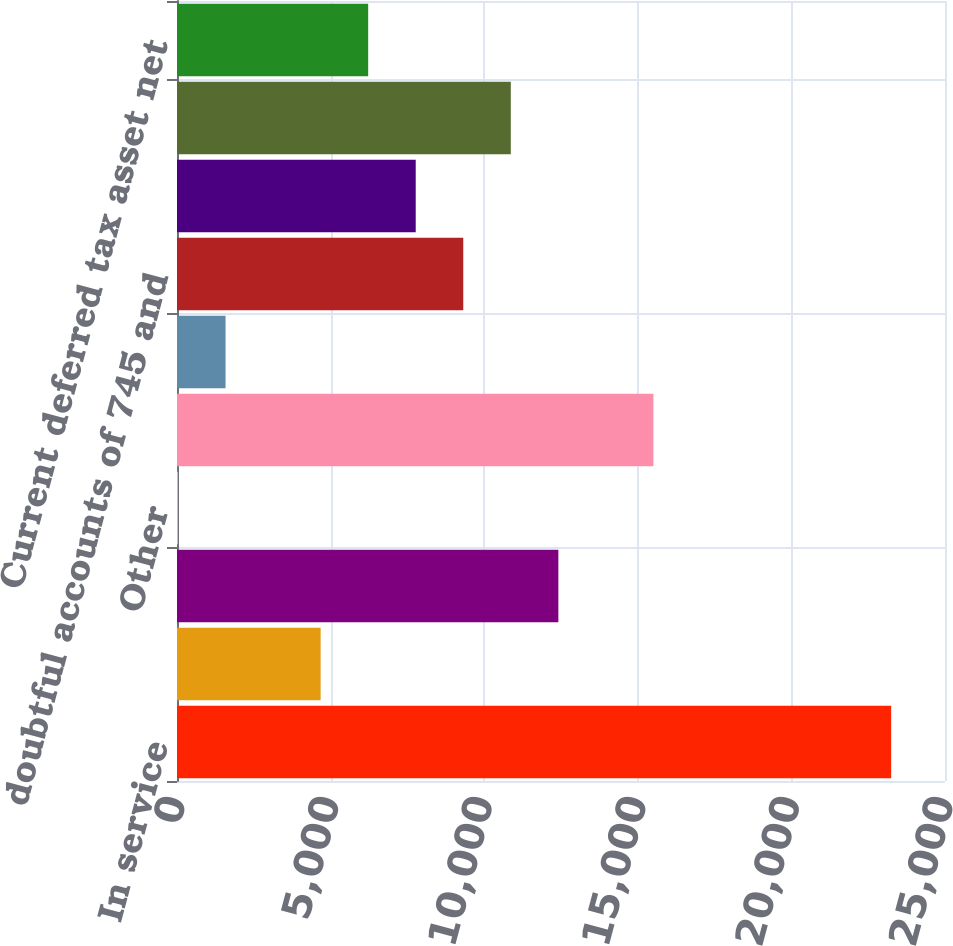Convert chart. <chart><loc_0><loc_0><loc_500><loc_500><bar_chart><fcel>In service<fcel>Construction work in progress<fcel>Equity investment in<fcel>Other<fcel>Total Investments<fcel>Cash and cash equivalents<fcel>doubtful accounts of 745 and<fcel>Accrued revenues<fcel>Materials supplies and<fcel>Current deferred tax asset net<nl><fcel>23247.1<fcel>4675.66<fcel>12413.8<fcel>32.8<fcel>15509<fcel>1580.42<fcel>9318.52<fcel>7770.9<fcel>10866.1<fcel>6223.28<nl></chart> 